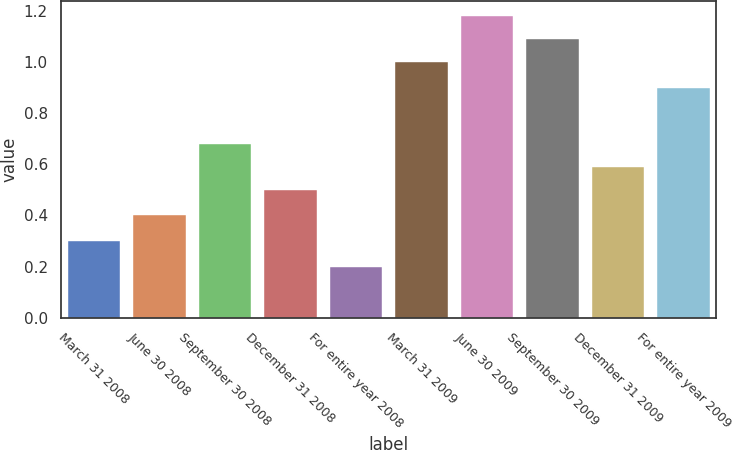Convert chart to OTSL. <chart><loc_0><loc_0><loc_500><loc_500><bar_chart><fcel>March 31 2008<fcel>June 30 2008<fcel>September 30 2008<fcel>December 31 2008<fcel>For entire year 2008<fcel>March 31 2009<fcel>June 30 2009<fcel>September 30 2009<fcel>December 31 2009<fcel>For entire year 2009<nl><fcel>0.3<fcel>0.4<fcel>0.68<fcel>0.5<fcel>0.2<fcel>1<fcel>1.18<fcel>1.09<fcel>0.59<fcel>0.9<nl></chart> 